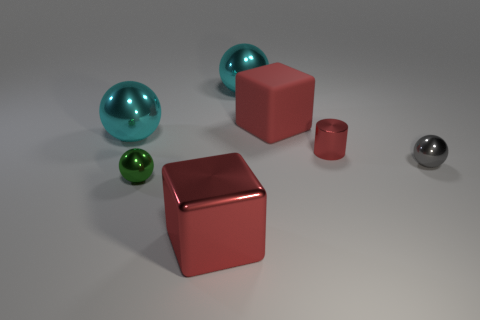What number of other objects are there of the same material as the tiny gray object?
Your response must be concise. 5. There is a metal cylinder; is it the same size as the red cube behind the tiny green metallic object?
Your response must be concise. No. What is the color of the metal cylinder?
Your answer should be very brief. Red. There is a red rubber object that is to the right of the ball behind the big red block that is behind the tiny gray object; what is its shape?
Provide a succinct answer. Cube. What material is the red block on the right side of the cyan sphere that is to the right of the green metal ball?
Your answer should be compact. Rubber. There is a small green thing that is the same material as the tiny gray ball; what shape is it?
Offer a very short reply. Sphere. Are there any other things that have the same shape as the small gray metallic object?
Give a very brief answer. Yes. There is a red metal block; what number of red cylinders are on the right side of it?
Offer a very short reply. 1. Is there a small green sphere?
Provide a short and direct response. Yes. The small shiny object in front of the metal thing that is to the right of the small metallic thing behind the gray object is what color?
Provide a short and direct response. Green. 